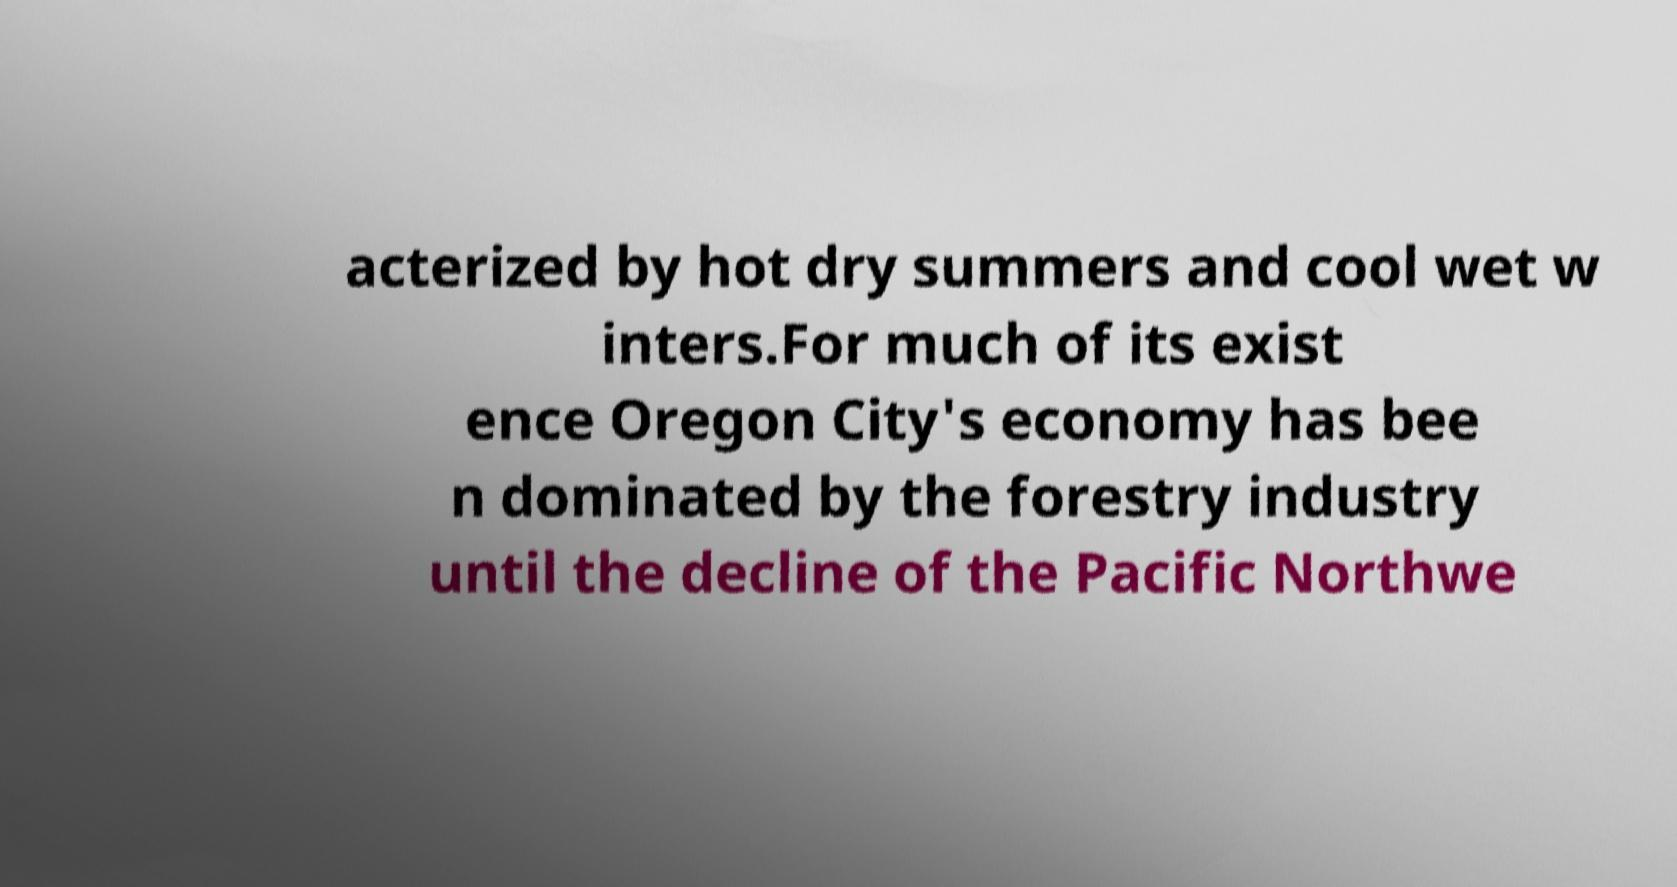For documentation purposes, I need the text within this image transcribed. Could you provide that? acterized by hot dry summers and cool wet w inters.For much of its exist ence Oregon City's economy has bee n dominated by the forestry industry until the decline of the Pacific Northwe 